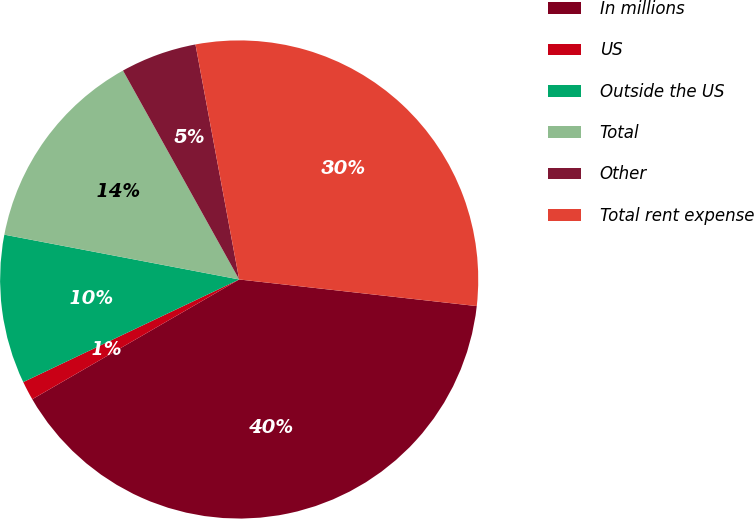<chart> <loc_0><loc_0><loc_500><loc_500><pie_chart><fcel>In millions<fcel>US<fcel>Outside the US<fcel>Total<fcel>Other<fcel>Total rent expense<nl><fcel>39.87%<fcel>1.29%<fcel>10.06%<fcel>13.92%<fcel>5.15%<fcel>29.7%<nl></chart> 